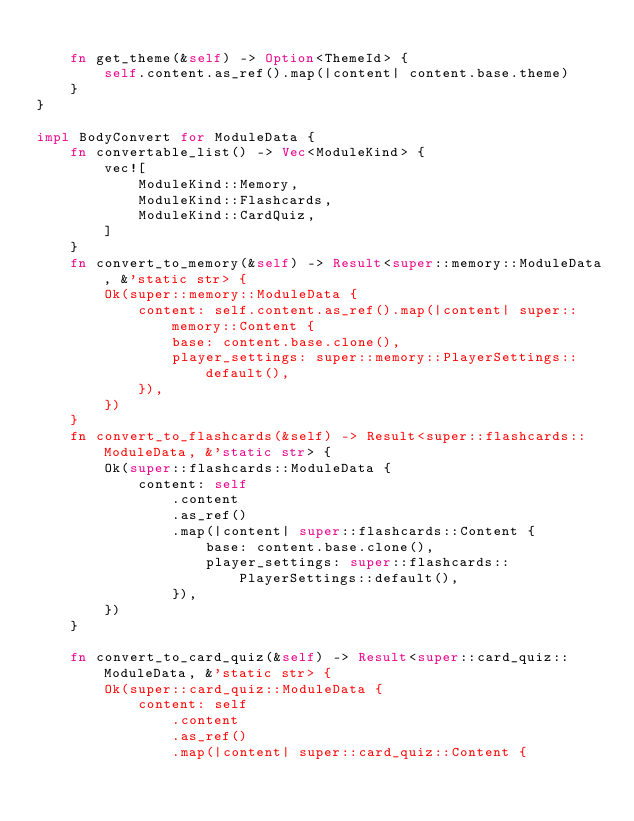Convert code to text. <code><loc_0><loc_0><loc_500><loc_500><_Rust_>
    fn get_theme(&self) -> Option<ThemeId> {
        self.content.as_ref().map(|content| content.base.theme)
    }
}

impl BodyConvert for ModuleData {
    fn convertable_list() -> Vec<ModuleKind> {
        vec![
            ModuleKind::Memory,
            ModuleKind::Flashcards,
            ModuleKind::CardQuiz,
        ]
    }
    fn convert_to_memory(&self) -> Result<super::memory::ModuleData, &'static str> {
        Ok(super::memory::ModuleData {
            content: self.content.as_ref().map(|content| super::memory::Content {
                base: content.base.clone(),
                player_settings: super::memory::PlayerSettings::default(),
            }),
        })
    }
    fn convert_to_flashcards(&self) -> Result<super::flashcards::ModuleData, &'static str> {
        Ok(super::flashcards::ModuleData {
            content: self
                .content
                .as_ref()
                .map(|content| super::flashcards::Content {
                    base: content.base.clone(),
                    player_settings: super::flashcards::PlayerSettings::default(),
                }),
        })
    }

    fn convert_to_card_quiz(&self) -> Result<super::card_quiz::ModuleData, &'static str> {
        Ok(super::card_quiz::ModuleData {
            content: self
                .content
                .as_ref()
                .map(|content| super::card_quiz::Content {</code> 